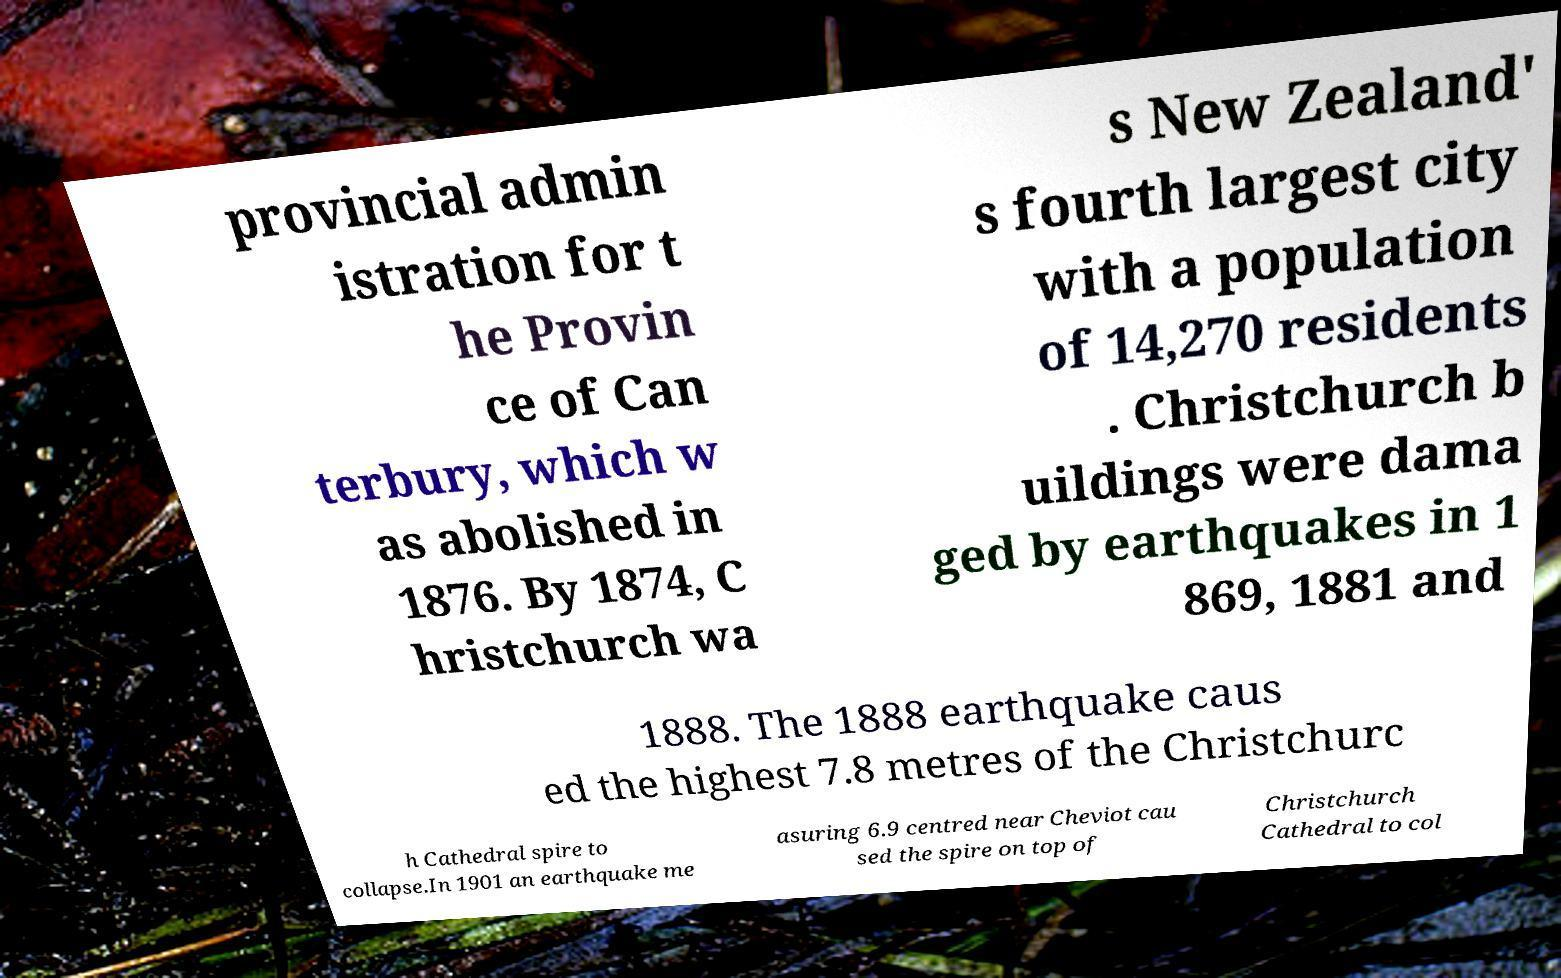Can you read and provide the text displayed in the image?This photo seems to have some interesting text. Can you extract and type it out for me? provincial admin istration for t he Provin ce of Can terbury, which w as abolished in 1876. By 1874, C hristchurch wa s New Zealand' s fourth largest city with a population of 14,270 residents . Christchurch b uildings were dama ged by earthquakes in 1 869, 1881 and 1888. The 1888 earthquake caus ed the highest 7.8 metres of the Christchurc h Cathedral spire to collapse.In 1901 an earthquake me asuring 6.9 centred near Cheviot cau sed the spire on top of Christchurch Cathedral to col 